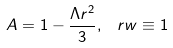Convert formula to latex. <formula><loc_0><loc_0><loc_500><loc_500>A = 1 - \frac { \Lambda r ^ { 2 } } { 3 } , \, \ r w \equiv 1</formula> 